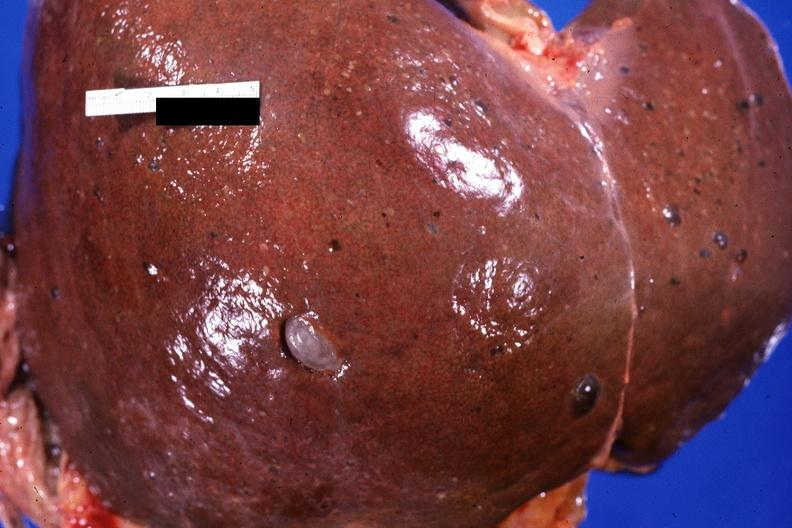does temporal muscle hemorrhage show liver, adult polycystic kidney?
Answer the question using a single word or phrase. No 